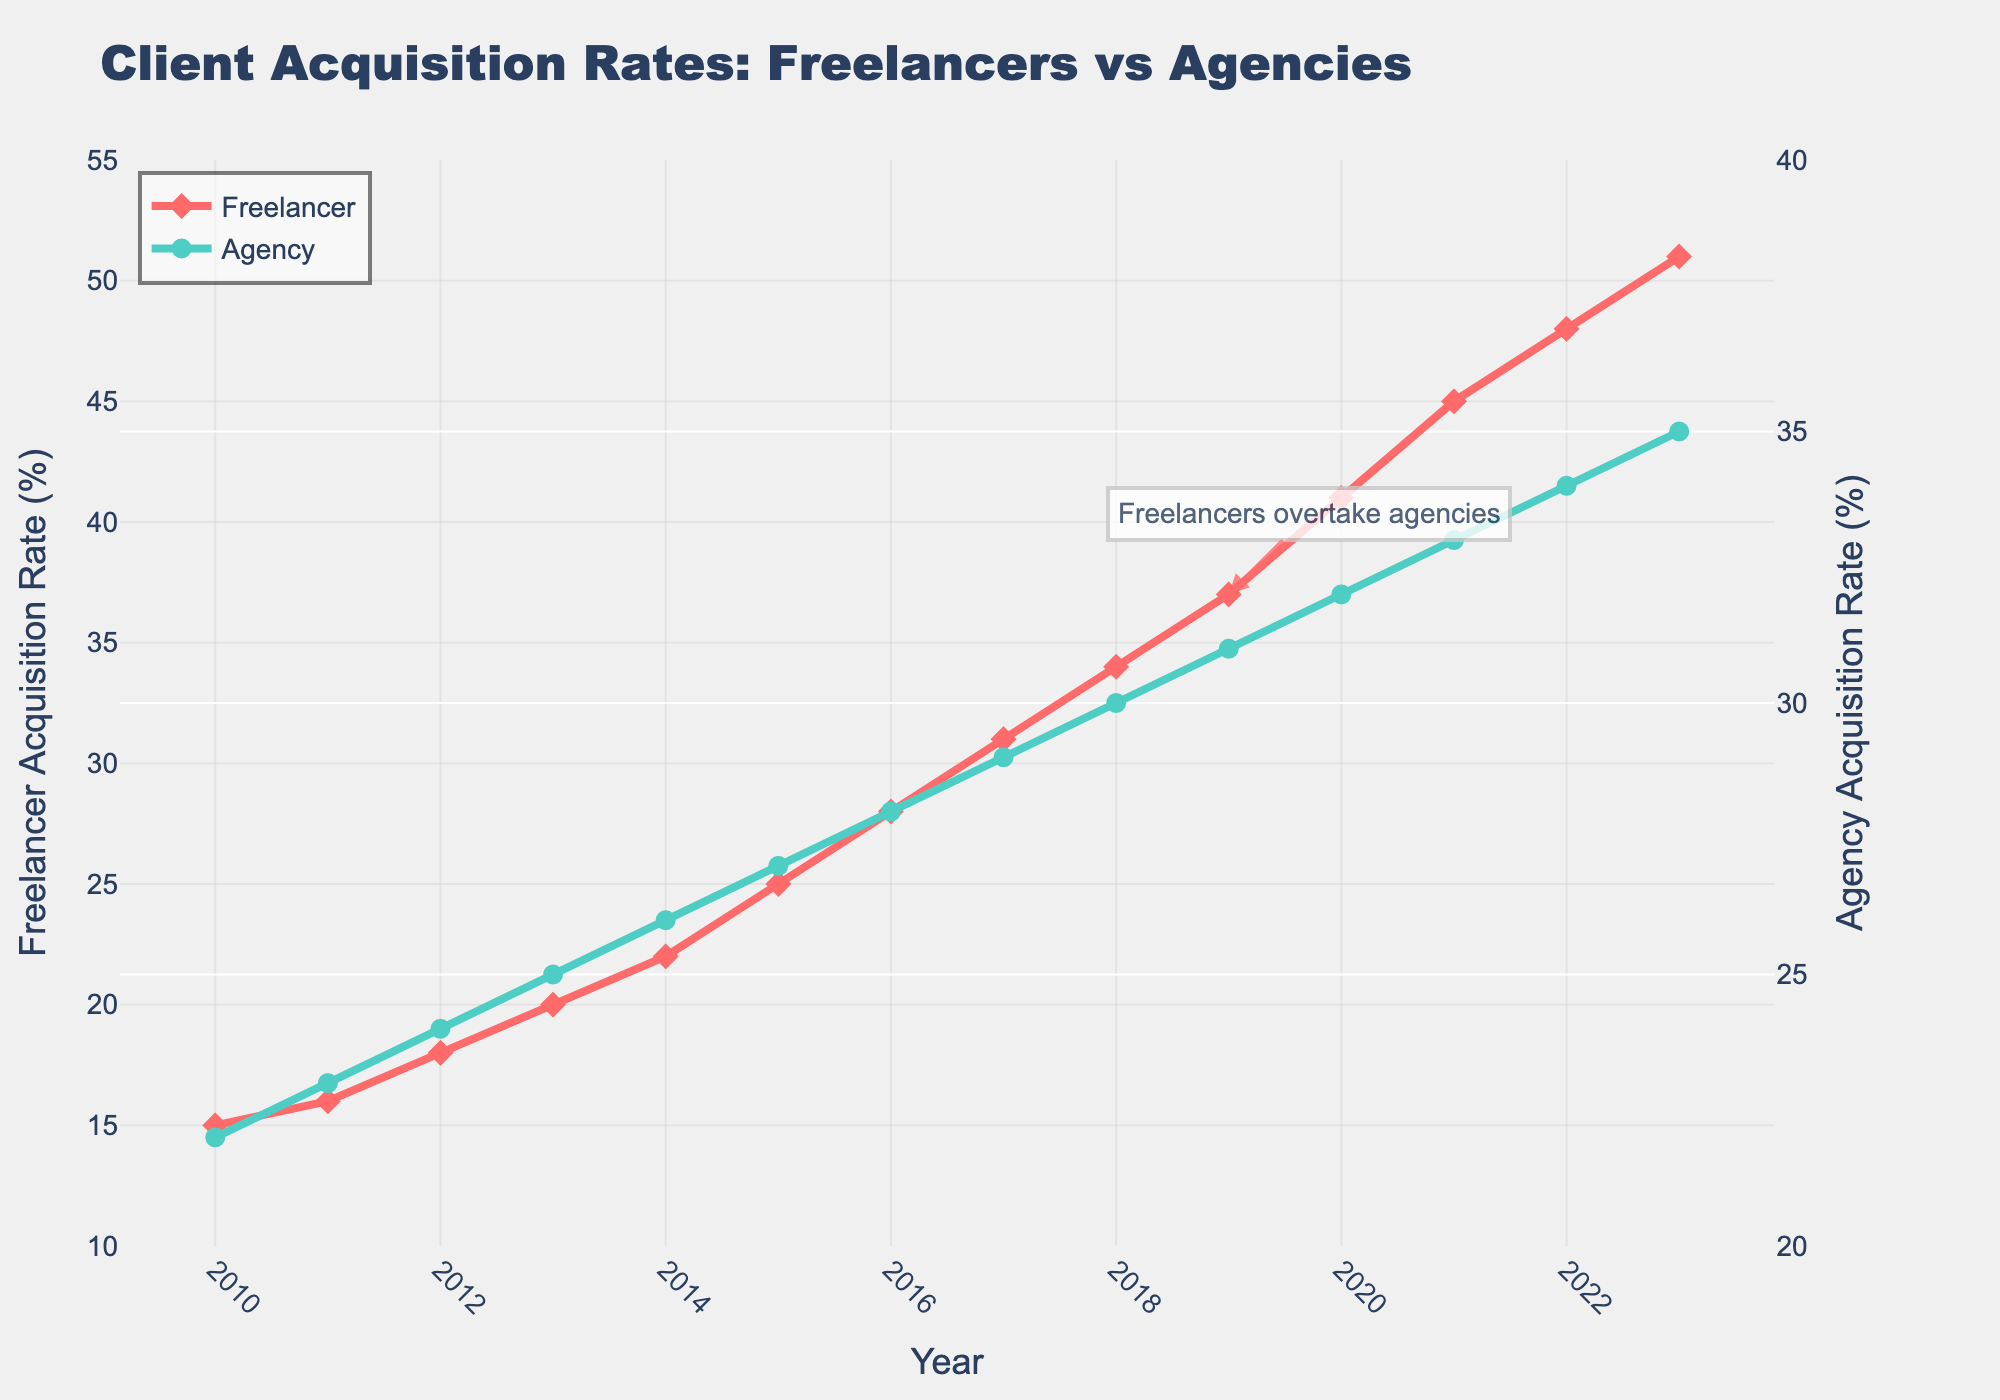What is the general trend of the Freelancer Acquisition Rate over time? The Freelancer Acquisition Rate increases steadily each year from 2010 to 2023, starting at 15% in 2010 and reaching 51% in 2023.
Answer: It increases steadily How many years did it take for freelancers to overtake agencies in client acquisition rates? Freelancers overtook agencies in 2019 when the Freelancer Acquisition Rate reached 37%, surpassing the Agency Acquisition Rate of 31%. This took 9 years, from 2010 to 2019.
Answer: 9 years What was the difference in client acquisition rates between freelancers and agencies in 2020? In 2020, the Freelancer Acquisition Rate was 41% and the Agency Acquisition Rate was 32%. The difference is 41% - 32% = 9%.
Answer: 9% During which year did freelancers and agencies have an equal client acquisition rate? The year when freelancers and agencies had an equal client acquisition rate is 2016, both at 28%.
Answer: 2016 Compare the rate of growth in client acquisition for freelancers versus agencies from 2010 to 2023. From 2010 to 2023, freelancers' acquisition rate increased from 15% to 51%, a difference of 36%. Agencies' acquisition rate increased from 22% to 35%, a difference of 13%. Freelancers grew faster.
Answer: Freelancers grew faster In which year did the Freelancer Acquisition Rate exceed 30% for the first time? The Freelancer Acquisition Rate exceeded 30% for the first time in 2017, when it reached 31%.
Answer: 2017 What is the average acquisition rate for the agencies over the entire period shown? To find the average, sum the Agency Acquisition Rates from 2010 to 2023 (22 + 23 + 24 + 25 + 26 + 27 + 28 + 29 + 30 + 31 + 32 + 33 + 34 + 35 = 399) and divide by the number of years (399/14 ≈ 28.5).
Answer: 28.5% Which two years show the most significant increase in the Freelancer Acquisition Rate? The most significant increases in the Freelancer Acquisition Rate occurred between 2019 to 2020 (37% to 41%) and 2020 to 2021 (41% to 45%).
Answer: 2019-2020, 2020-2021 What is the visual difference in markers between freelancers and agencies in the plot? Freelancers' markers are diamonds and the color is red, while agencies' markers are circles and the color is green.
Answer: Diamonds and red vs. circles and green What can you infer from the annotation "Freelancers overtake agencies" in the plot? The annotation "Freelancers overtake agencies" indicates the year (2019) when the Freelancer Acquisition Rate overtook the Agency Acquisition Rate for the first time. It visually emphasizes this significant milestone.
Answer: Freelancers overtook agencies in 2019 